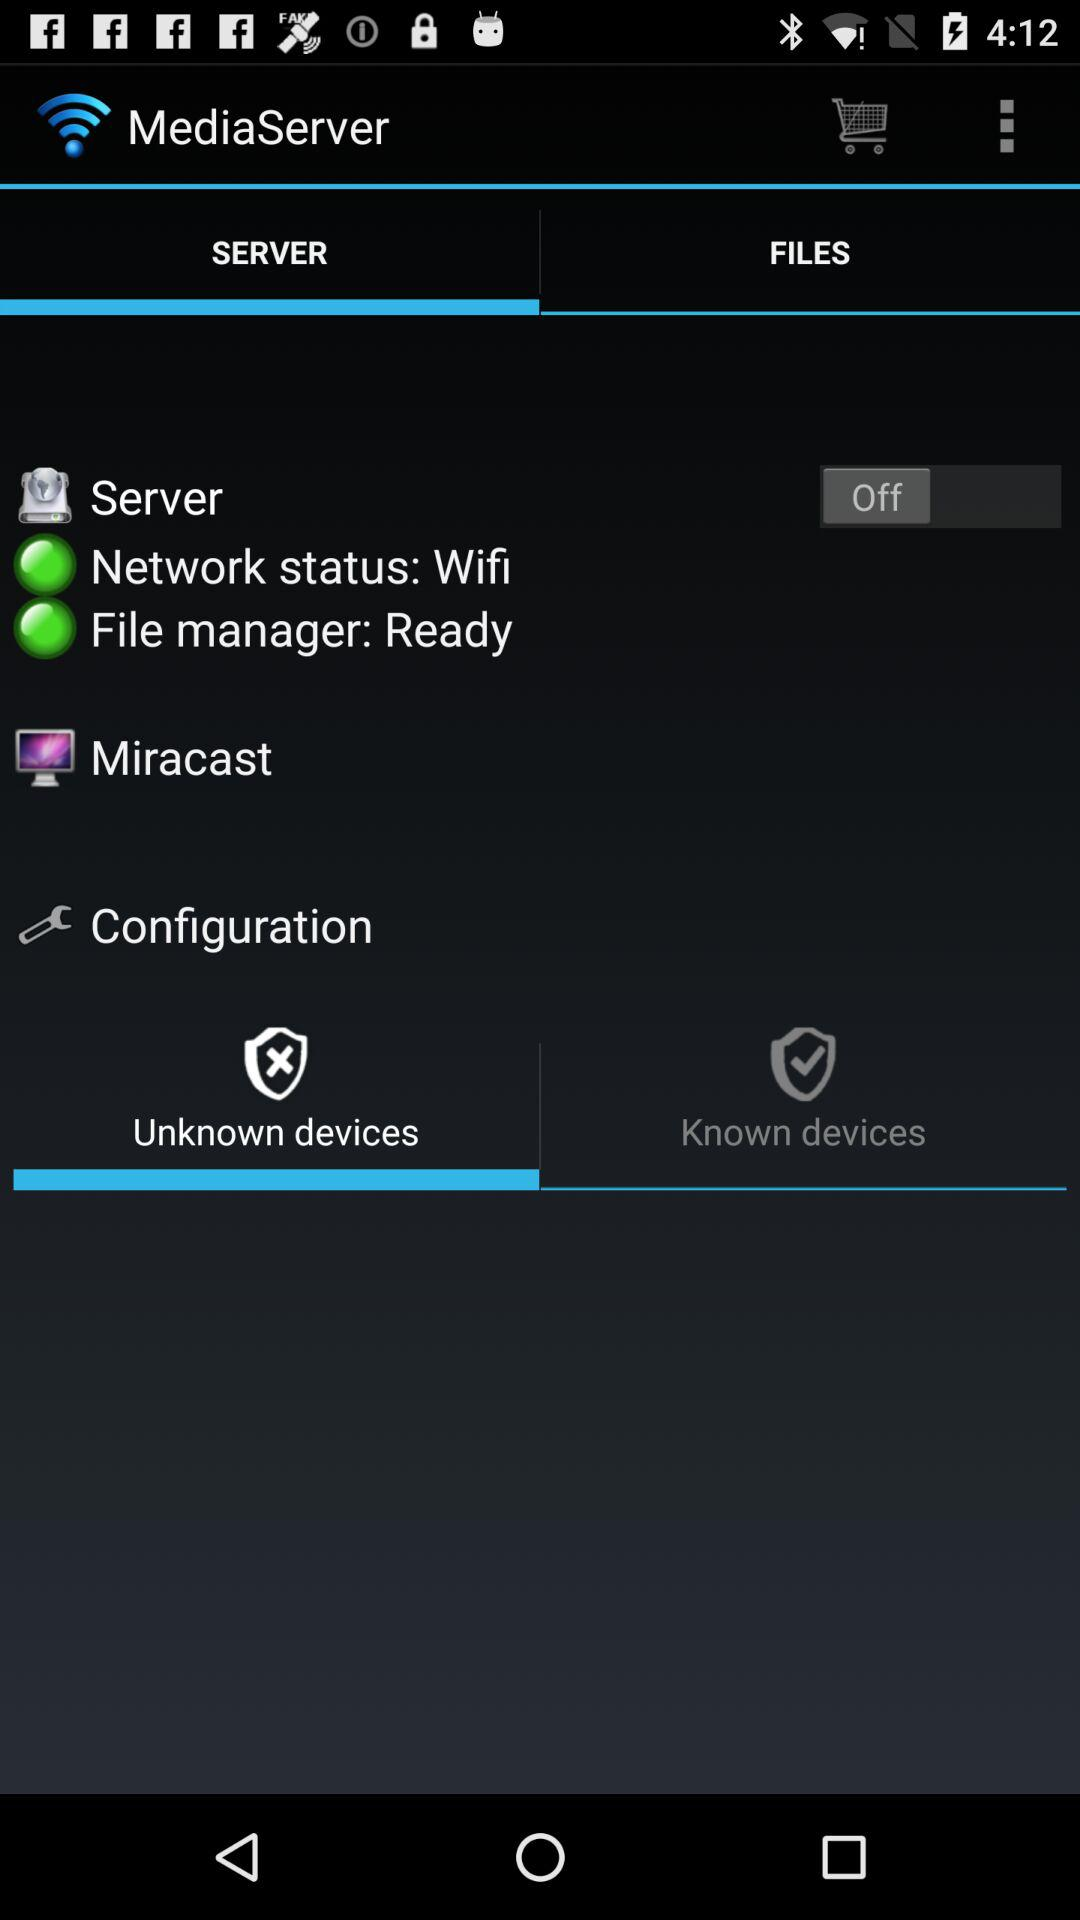What is the status of the "Server"? The status is "off". 